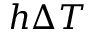<formula> <loc_0><loc_0><loc_500><loc_500>h \Delta T</formula> 